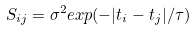<formula> <loc_0><loc_0><loc_500><loc_500>S _ { i j } = \sigma ^ { 2 } e x p ( - | t _ { i } - t _ { j } | / \tau )</formula> 